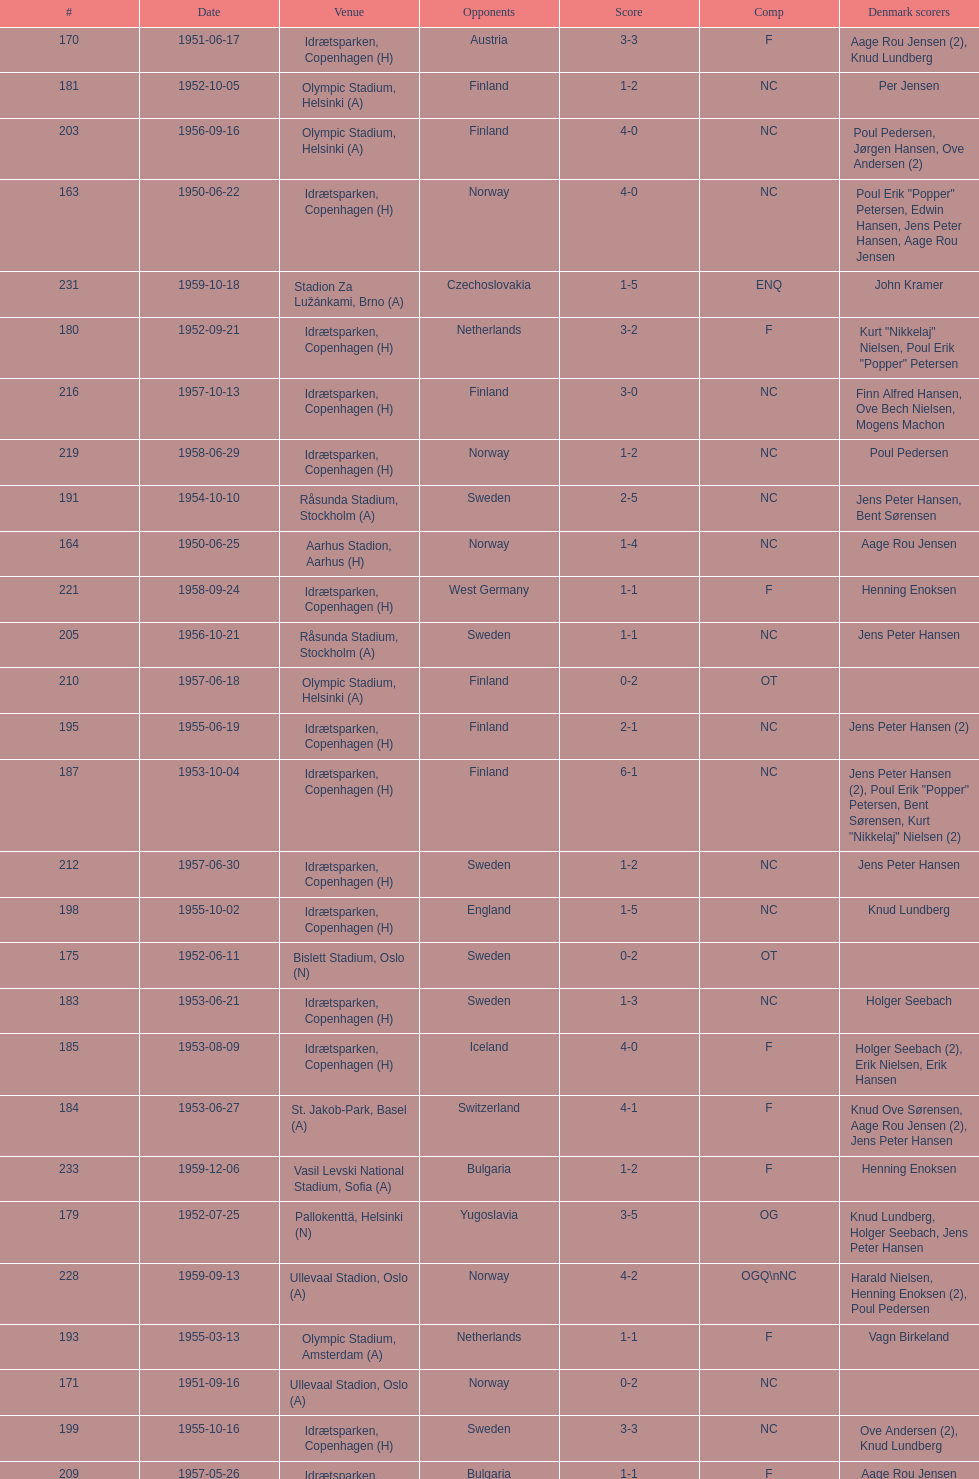What is the venue right below jna stadium, belgrade (a)? Idrætsparken, Copenhagen (H). 